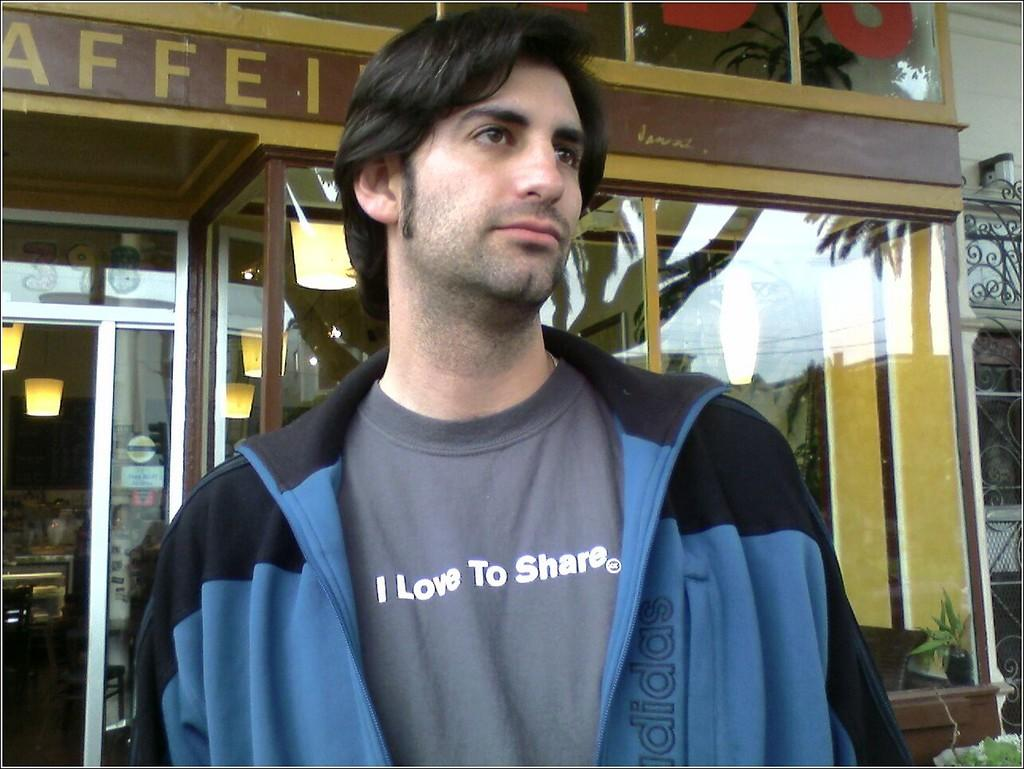What is the person in the image doing? The person is standing in the image. What is the person wearing? The person is wearing a blue and black color jacket. What can be seen in the background of the image? There is a store visible in the background, along with a glass door and lights. What might be inside the store? There are objects visible inside the store. What type of hammer is the person using to represent their country on stage? There is no hammer, representative, or stage present in the image. The person is simply standing and wearing a jacket. 